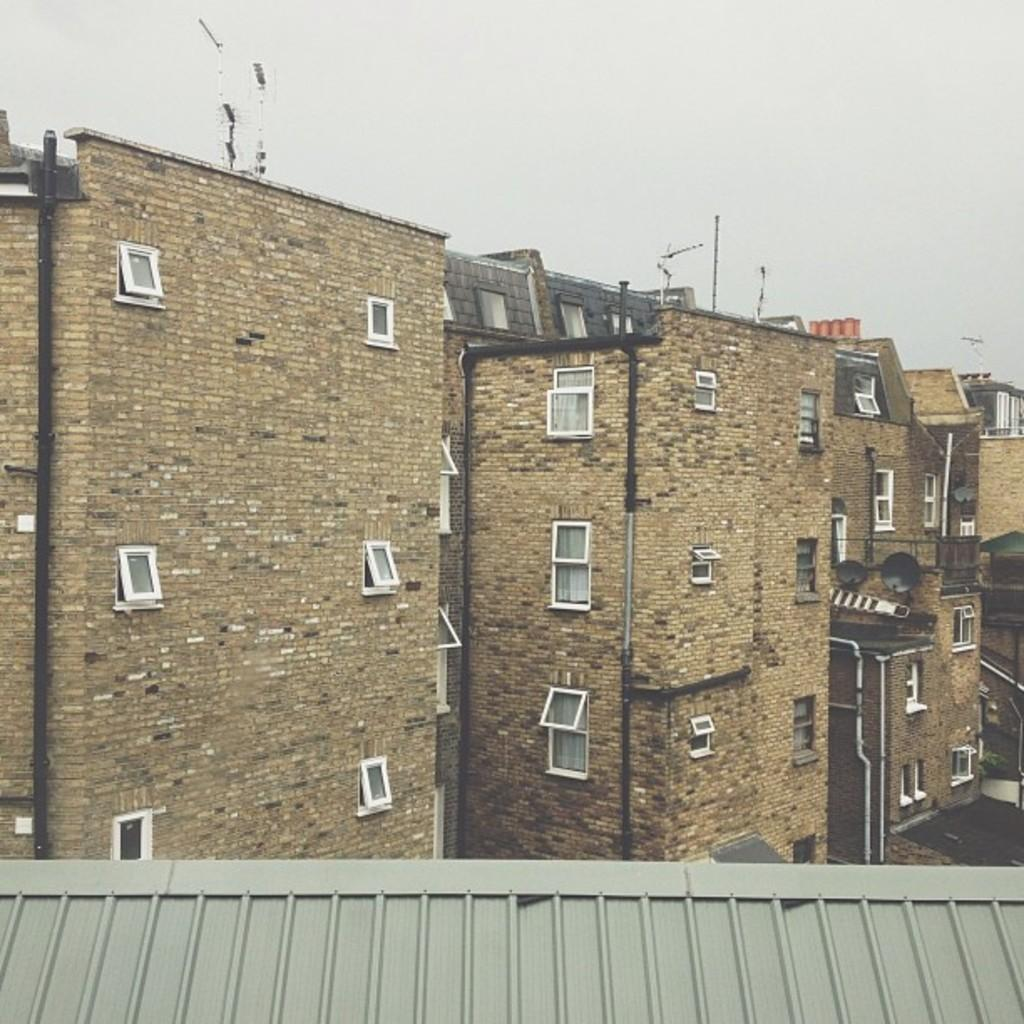What type of structures can be seen in the image? There are buildings in the image. What part of the natural environment is visible in the image? The sky is visible at the top of the image. Can you describe the bottom part of the image? The roof of a building is visible at the bottom of the image. How many nuts are present on the roof of the building in the image? There are no nuts visible on the roof of the building in the image. 